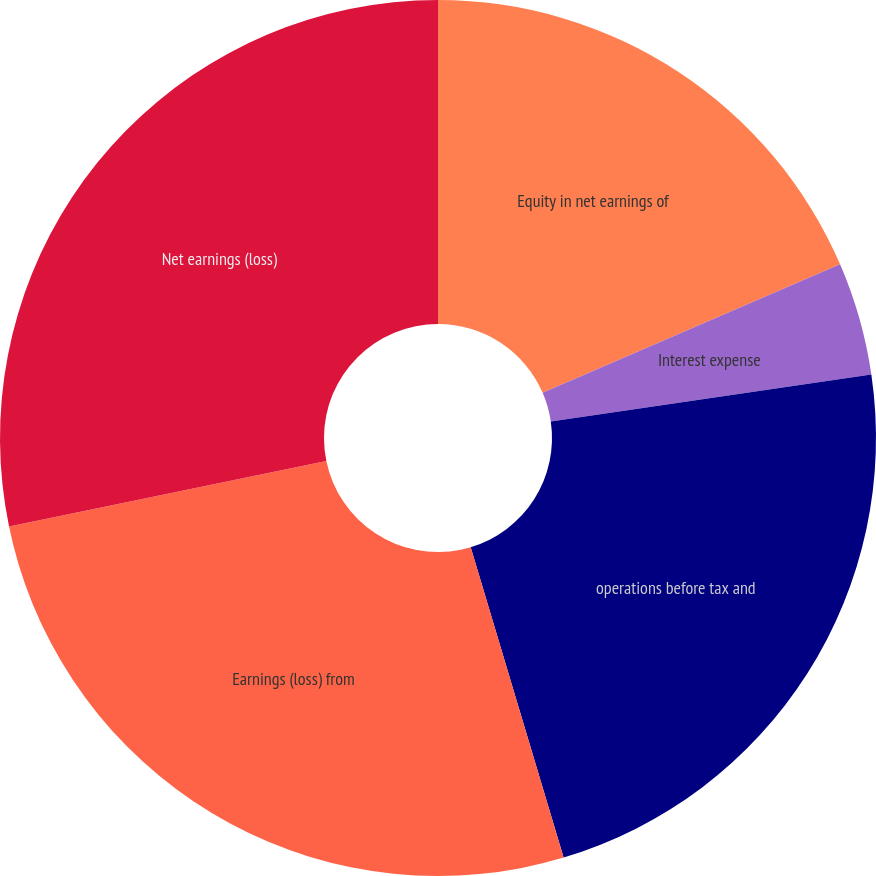Convert chart to OTSL. <chart><loc_0><loc_0><loc_500><loc_500><pie_chart><fcel>Equity in net earnings of<fcel>Interest expense<fcel>operations before tax and<fcel>Earnings (loss) from<fcel>Net earnings (loss)<nl><fcel>18.51%<fcel>4.17%<fcel>22.69%<fcel>26.39%<fcel>28.24%<nl></chart> 